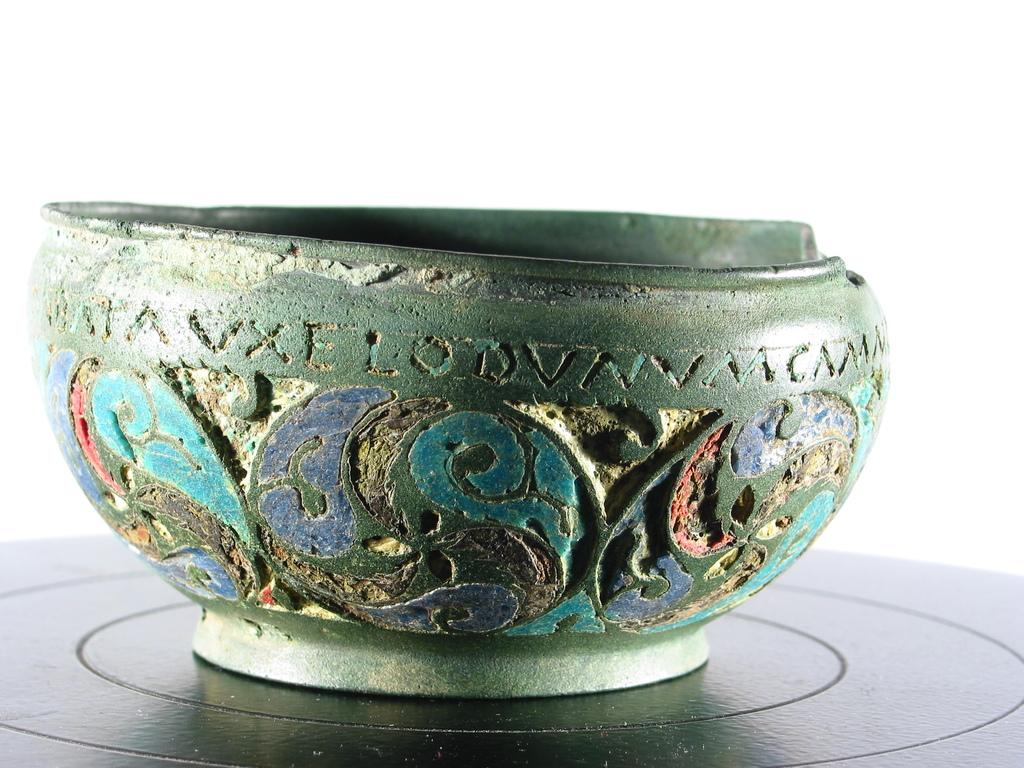What is the main object in the image? There is a bowl in the image. What is the color of the surface the bowl is on? The bowl is on a black surface. What can be seen on the bowl itself? The bowl has text and design on it. What color is the background of the image? The background of the image is white. How many ants can be seen crawling on the blade in the image? There are no ants or blades present in the image; it only features a bowl on a black surface with a white background. 